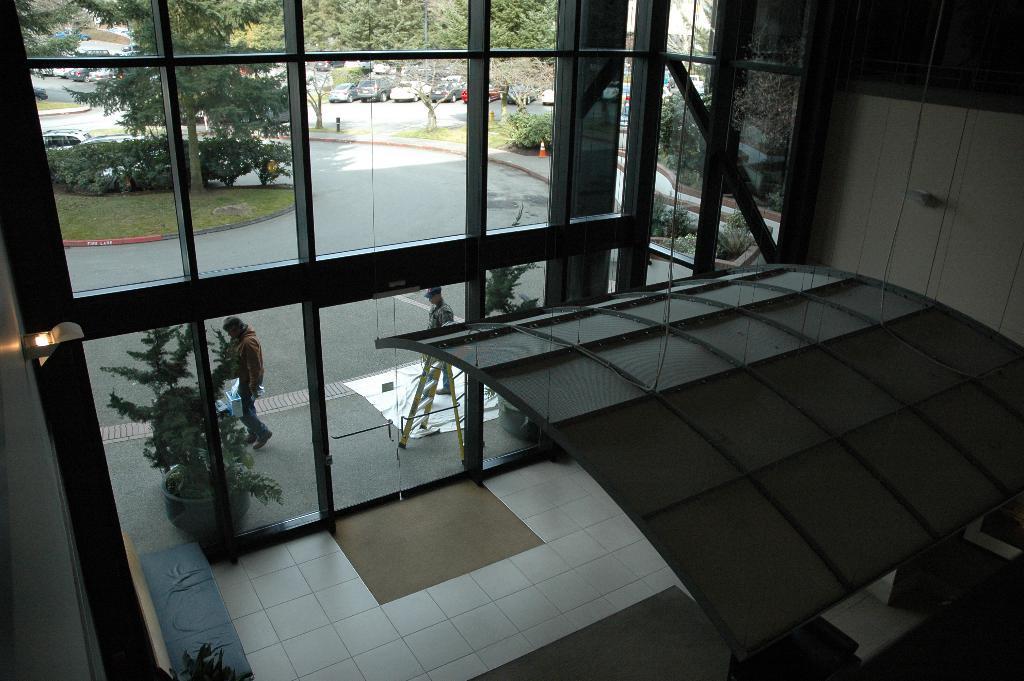How would you summarize this image in a sentence or two? In this picture we can observe a building. There are glass doors. There are two persons in front of these glass doors. There are some plants and some grass on the ground. There is a road. We can observe vehicles parked on the road here. In the background there are trees. 